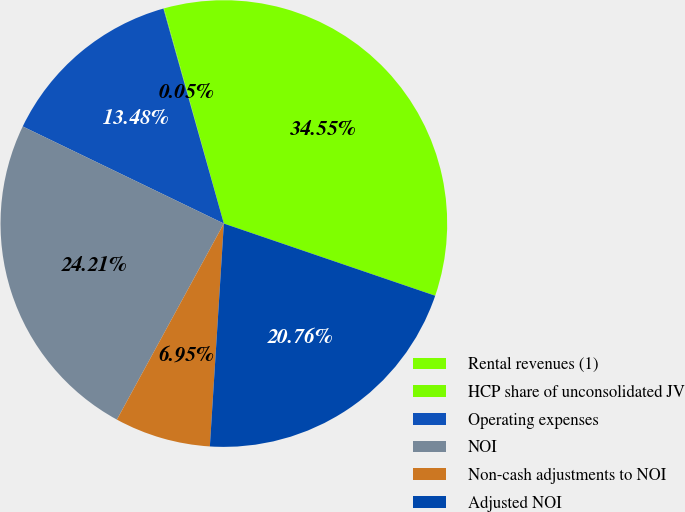Convert chart. <chart><loc_0><loc_0><loc_500><loc_500><pie_chart><fcel>Rental revenues (1)<fcel>HCP share of unconsolidated JV<fcel>Operating expenses<fcel>NOI<fcel>Non-cash adjustments to NOI<fcel>Adjusted NOI<nl><fcel>34.55%<fcel>0.05%<fcel>13.48%<fcel>24.21%<fcel>6.95%<fcel>20.76%<nl></chart> 